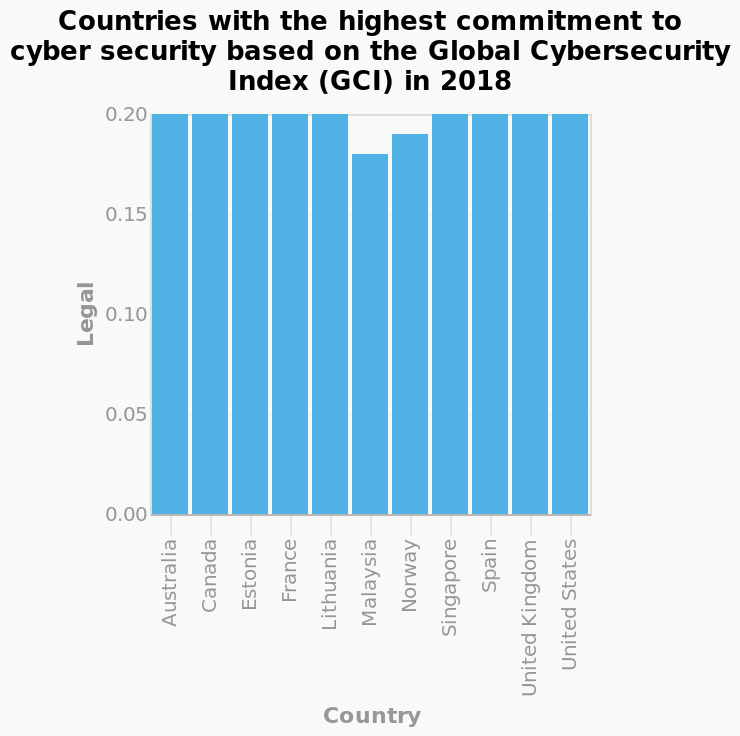<image>
Is Norway committed to cyber security?  No, Norway does not have an equally high commitment to cyber security. Are there any exceptions to the high commitment to cyber security? Yes, Norway and Malaysia are the exceptions as they do not have an equally high commitment to cyber security. Which two countries are plotted on the extreme ends of the x-axis? The countries plotted on the extreme ends of the x-axis in the bar graph are Australia and the United States. Australia is located at one end, while the United States is at the other end. Are Australia and the United States located at the same end in the bar graph? No.The countries plotted on the extreme ends of the x-axis in the bar graph are Australia and the United States. Australia is located at one end, while the United States is at the other end. 